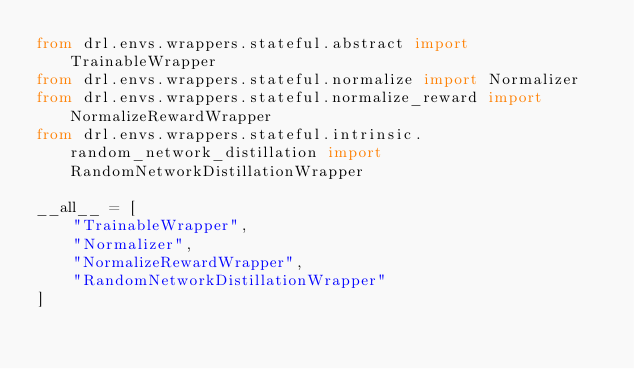Convert code to text. <code><loc_0><loc_0><loc_500><loc_500><_Python_>from drl.envs.wrappers.stateful.abstract import TrainableWrapper
from drl.envs.wrappers.stateful.normalize import Normalizer
from drl.envs.wrappers.stateful.normalize_reward import NormalizeRewardWrapper
from drl.envs.wrappers.stateful.intrinsic.random_network_distillation import RandomNetworkDistillationWrapper

__all__ = [
    "TrainableWrapper",
    "Normalizer",
    "NormalizeRewardWrapper",
    "RandomNetworkDistillationWrapper"
]
</code> 